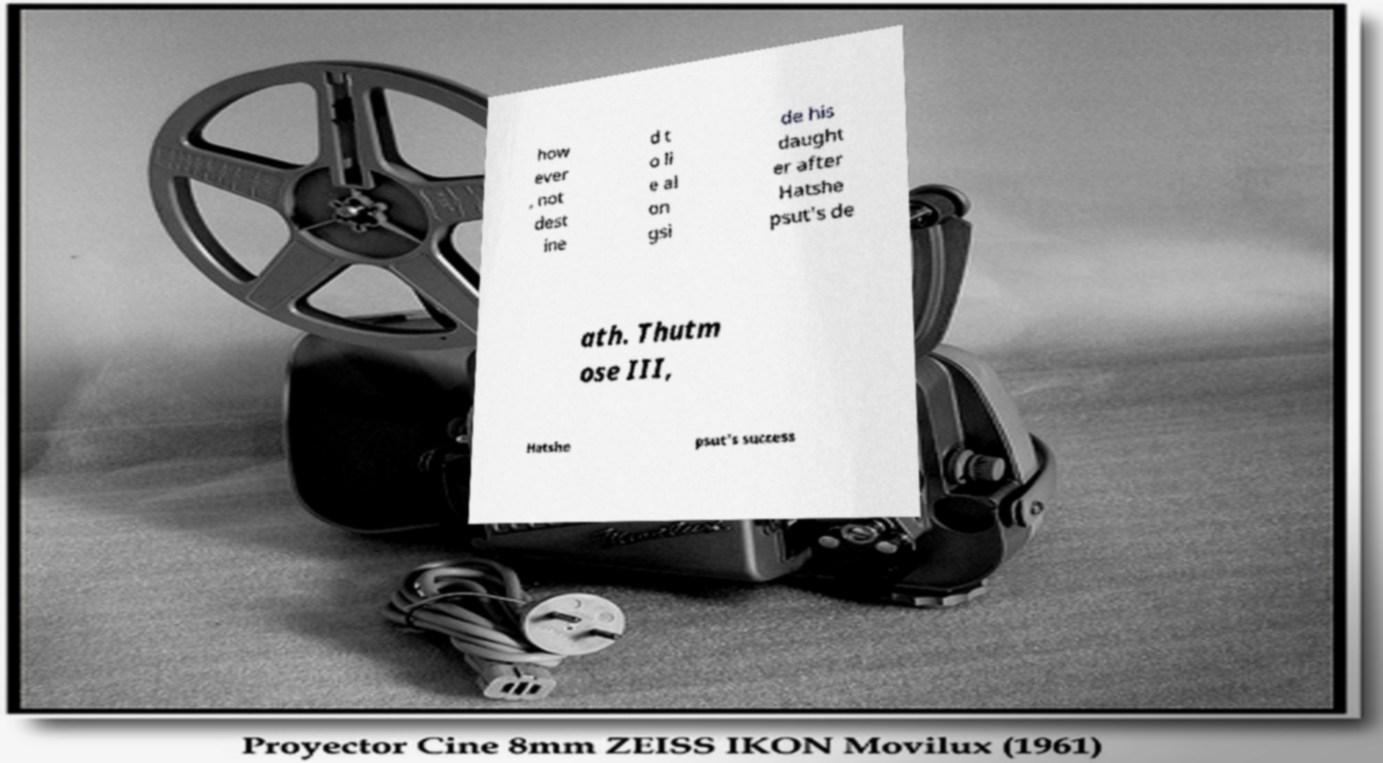What messages or text are displayed in this image? I need them in a readable, typed format. how ever , not dest ine d t o li e al on gsi de his daught er after Hatshe psut's de ath. Thutm ose III, Hatshe psut's success 